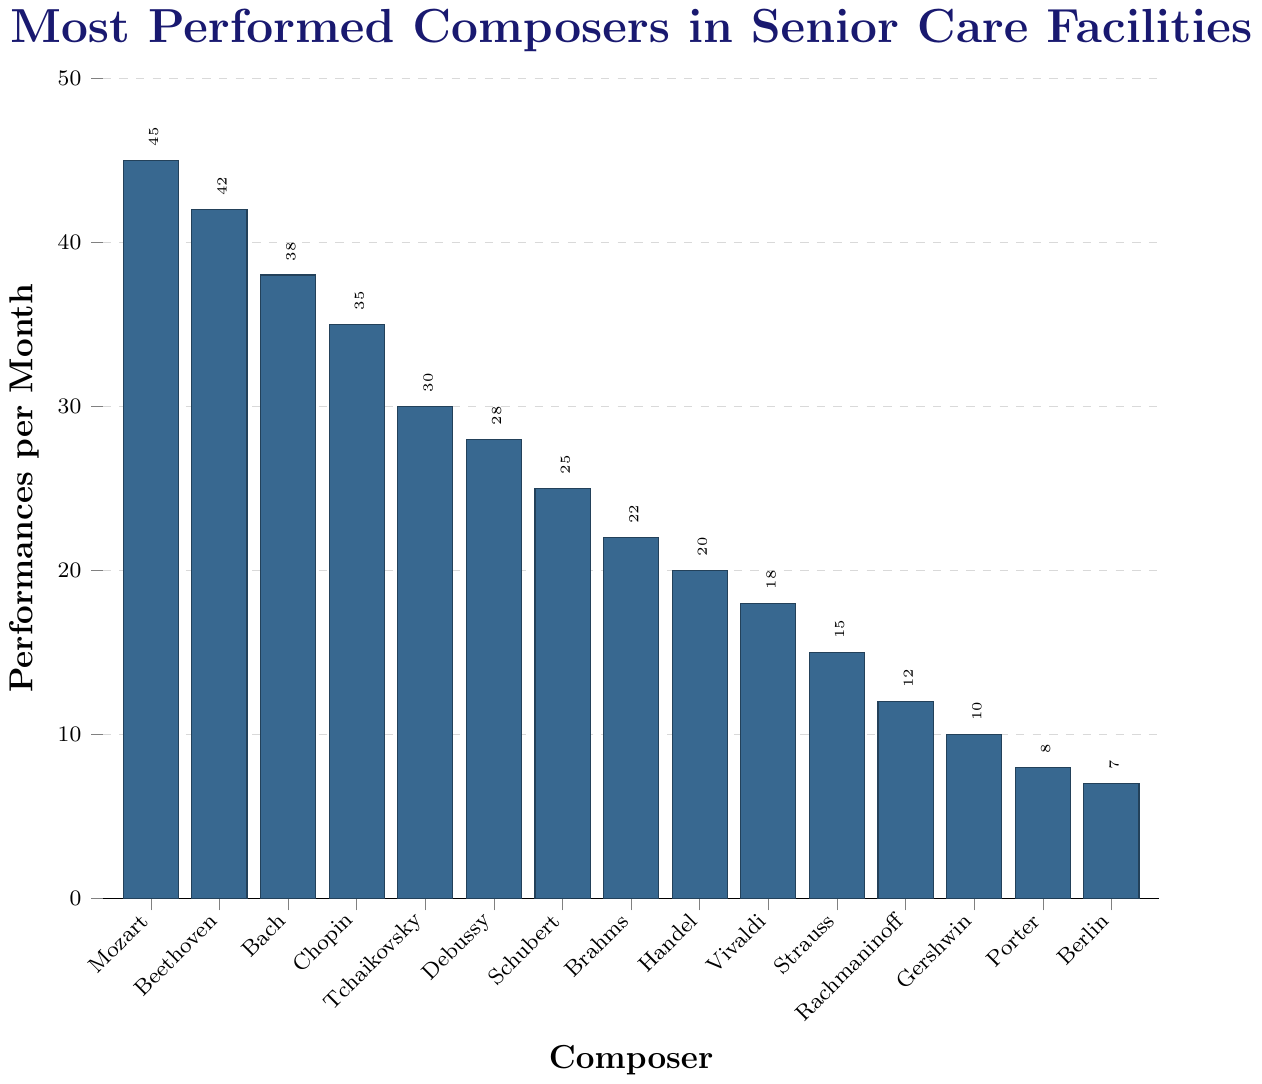Which composer has the highest number of performances per month? The highest bar represents Mozart with 45 performances per month, as the y-axis shows the frequency, and the bar for Mozart reaches the top value.
Answer: Mozart Which two composers have the closest number of performances per month? By examining the lengths of the bars and their adjacent values, Beethoven and Bach have close frequencies, with 42 and 38 performances per month, respectively.
Answer: Beethoven and Bach What's the total number of performances per month for the top three composers? The frequencies for the top three composers (Mozart: 45, Beethoven: 42, Bach: 38) add up to 125. 45 + 42 + 38 = 125.
Answer: 125 What's the difference in the number of performances between Mozart and Berlin? Mozart has 45 performances per month and Berlin has 7, so the difference is 45 - 7 = 38.
Answer: 38 Which composer has fewer performances per month: Schubert or Brahms? Comparing the bar lengths, Schubert has 25 performances per month while Brahms has 22. Brahms has fewer performances.
Answer: Brahms How many composers have performances per month greater than 30? By examining bar heights above the 30 mark on the y-axis, there are five composers (Mozart, Beethoven, Bach, Chopin, and Tchaikovsky).
Answer: 5 What's the sum of performances per month for Chopin, Tchaikovsky, and Debussy? The performances are Chopin: 35, Tchaikovsky: 30, Debussy: 28. The sum is 35 + 30 + 28 = 93.
Answer: 93 Which composers have performances per month less than 20 but more than 10? From the bars with frequencies in this range, they are: Vivaldi, Strauss, and Rachmaninoff with 18, 15, and 12 performances respectively.
Answer: Vivaldi, Strauss, and Rachmaninoff What's the median number of performances per month? (Consider all composers) Sort the frequencies in ascending order: 7, 8, 10, 12, 15, 18, 20, 22, 25, 28, 30, 35, 38, 42, 45. The middle value in the sorted list, with 15 values, is the 8th value = 22.
Answer: 22 